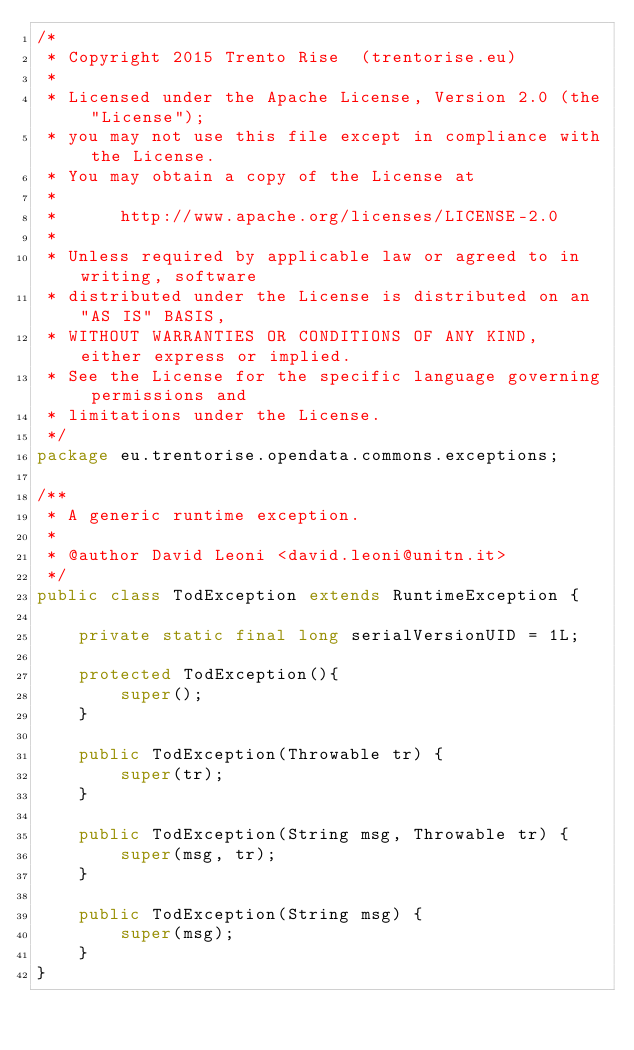<code> <loc_0><loc_0><loc_500><loc_500><_Java_>/* 
 * Copyright 2015 Trento Rise  (trentorise.eu) 
 *
 * Licensed under the Apache License, Version 2.0 (the "License");
 * you may not use this file except in compliance with the License.
 * You may obtain a copy of the License at
 *
 *      http://www.apache.org/licenses/LICENSE-2.0
 *
 * Unless required by applicable law or agreed to in writing, software
 * distributed under the License is distributed on an "AS IS" BASIS,
 * WITHOUT WARRANTIES OR CONDITIONS OF ANY KIND, either express or implied.
 * See the License for the specific language governing permissions and
 * limitations under the License.
 */
package eu.trentorise.opendata.commons.exceptions;

/**
 * A generic runtime exception. 
 * 
 * @author David Leoni <david.leoni@unitn.it>
 */
public class TodException extends RuntimeException {
    
    private static final long serialVersionUID = 1L;

    protected TodException(){
        super();
    }
    
    public TodException(Throwable tr) {
        super(tr);
    }

    public TodException(String msg, Throwable tr) {
        super(msg, tr);
    }

    public TodException(String msg) {
        super(msg);
    }
}
</code> 